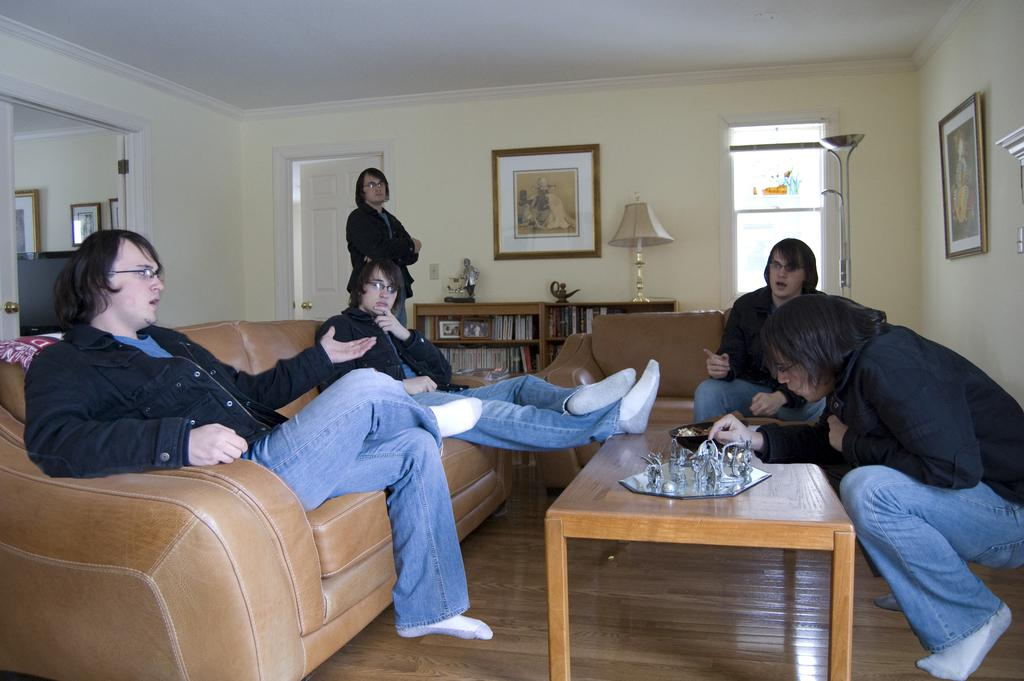What are the people in the image doing? There are people sitting on the sofa in the image. Can you describe the person in the background? There is a person standing at the door in the background. What can be seen on the wall in the image? There are frames on the wall in the image. How many tables are in the room? There are tables in the room, but the exact number is not specified. What is a feature of the room that allows light to enter? There is a window in the room. What is a source of light in the room? There is a lamp in the room. What shape is the sofa in the image? The shape of the sofa is not specified in the image. How does the person at the door turn into a cat in the image? There is no person turning into a cat in the image; the person is simply standing at the door. 